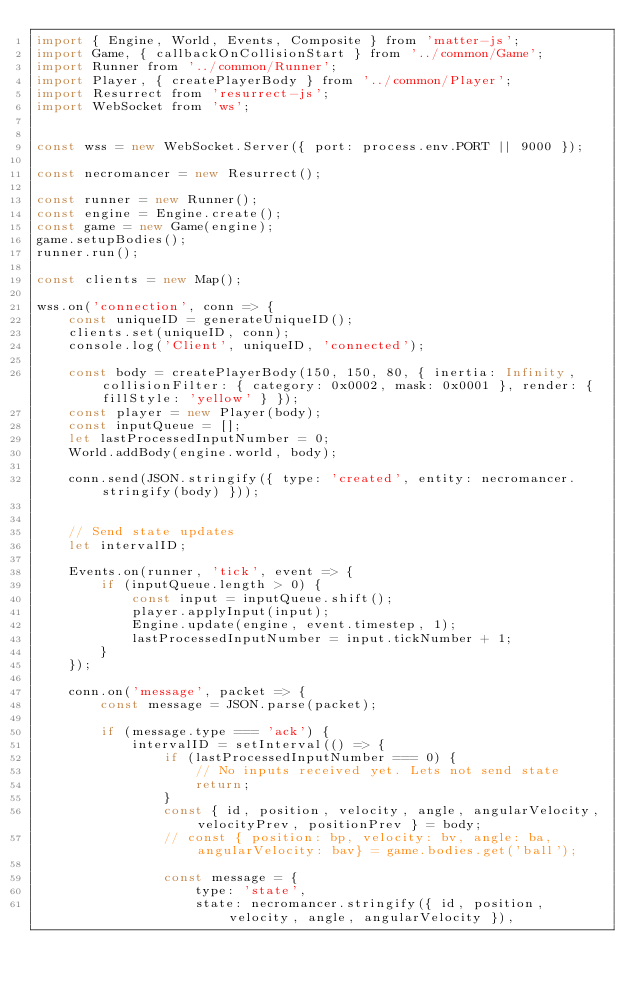<code> <loc_0><loc_0><loc_500><loc_500><_JavaScript_>import { Engine, World, Events, Composite } from 'matter-js';
import Game, { callbackOnCollisionStart } from '../common/Game';
import Runner from '../common/Runner';
import Player, { createPlayerBody } from '../common/Player';
import Resurrect from 'resurrect-js';
import WebSocket from 'ws';


const wss = new WebSocket.Server({ port: process.env.PORT || 9000 });

const necromancer = new Resurrect();

const runner = new Runner();
const engine = Engine.create();
const game = new Game(engine);
game.setupBodies();
runner.run();

const clients = new Map();

wss.on('connection', conn => {
    const uniqueID = generateUniqueID();
    clients.set(uniqueID, conn);
    console.log('Client', uniqueID, 'connected');

    const body = createPlayerBody(150, 150, 80, { inertia: Infinity, collisionFilter: { category: 0x0002, mask: 0x0001 }, render: { fillStyle: 'yellow' } });
    const player = new Player(body);
    const inputQueue = [];
    let lastProcessedInputNumber = 0;
    World.addBody(engine.world, body);

    conn.send(JSON.stringify({ type: 'created', entity: necromancer.stringify(body) }));


    // Send state updates
    let intervalID;

    Events.on(runner, 'tick', event => {
        if (inputQueue.length > 0) {
            const input = inputQueue.shift();
            player.applyInput(input);
            Engine.update(engine, event.timestep, 1);
            lastProcessedInputNumber = input.tickNumber + 1;
        }
    });

    conn.on('message', packet => {
        const message = JSON.parse(packet);

        if (message.type === 'ack') {
            intervalID = setInterval(() => {
                if (lastProcessedInputNumber === 0) {
                    // No inputs received yet. Lets not send state
                    return;
                }
                const { id, position, velocity, angle, angularVelocity, velocityPrev, positionPrev } = body;
                // const { position: bp, velocity: bv, angle: ba, angularVelocity: bav} = game.bodies.get('ball');

                const message = {
                    type: 'state',
                    state: necromancer.stringify({ id, position, velocity, angle, angularVelocity }),</code> 